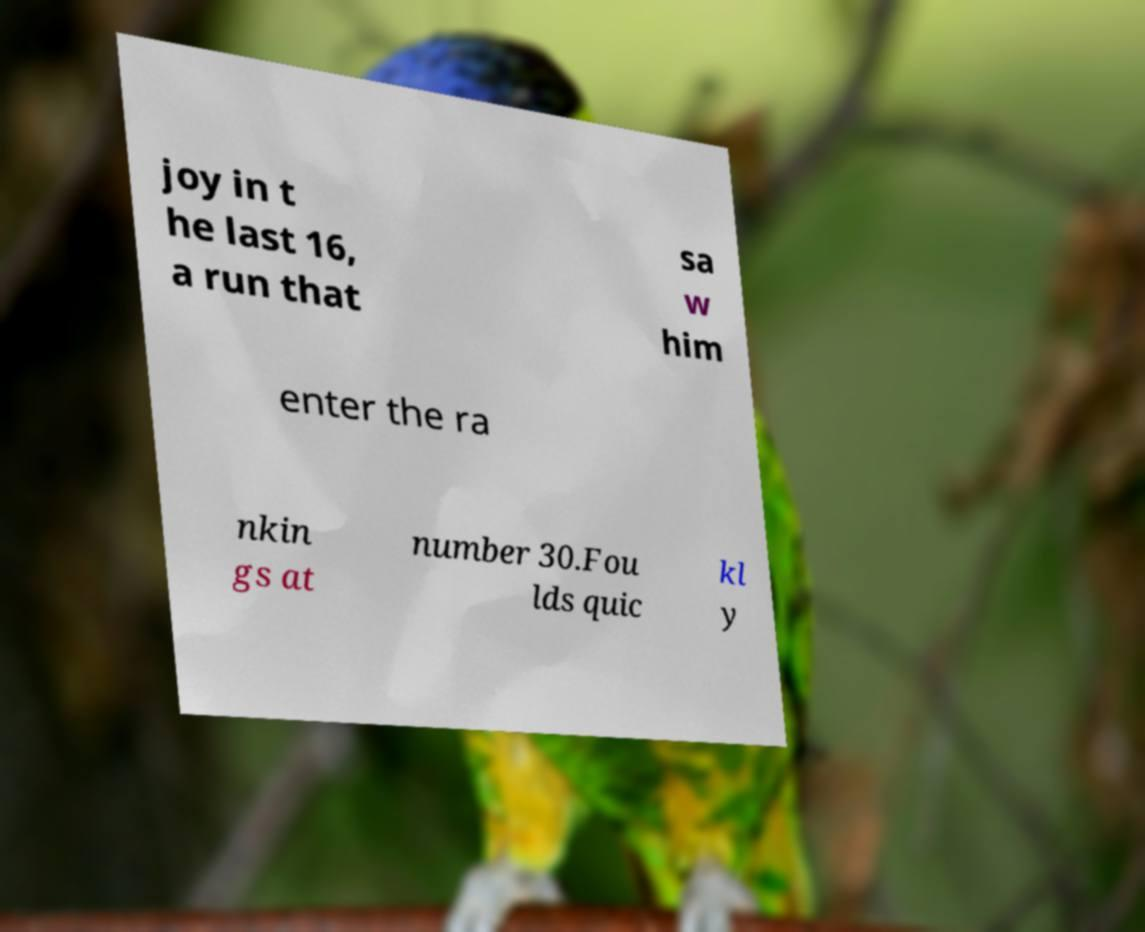There's text embedded in this image that I need extracted. Can you transcribe it verbatim? joy in t he last 16, a run that sa w him enter the ra nkin gs at number 30.Fou lds quic kl y 